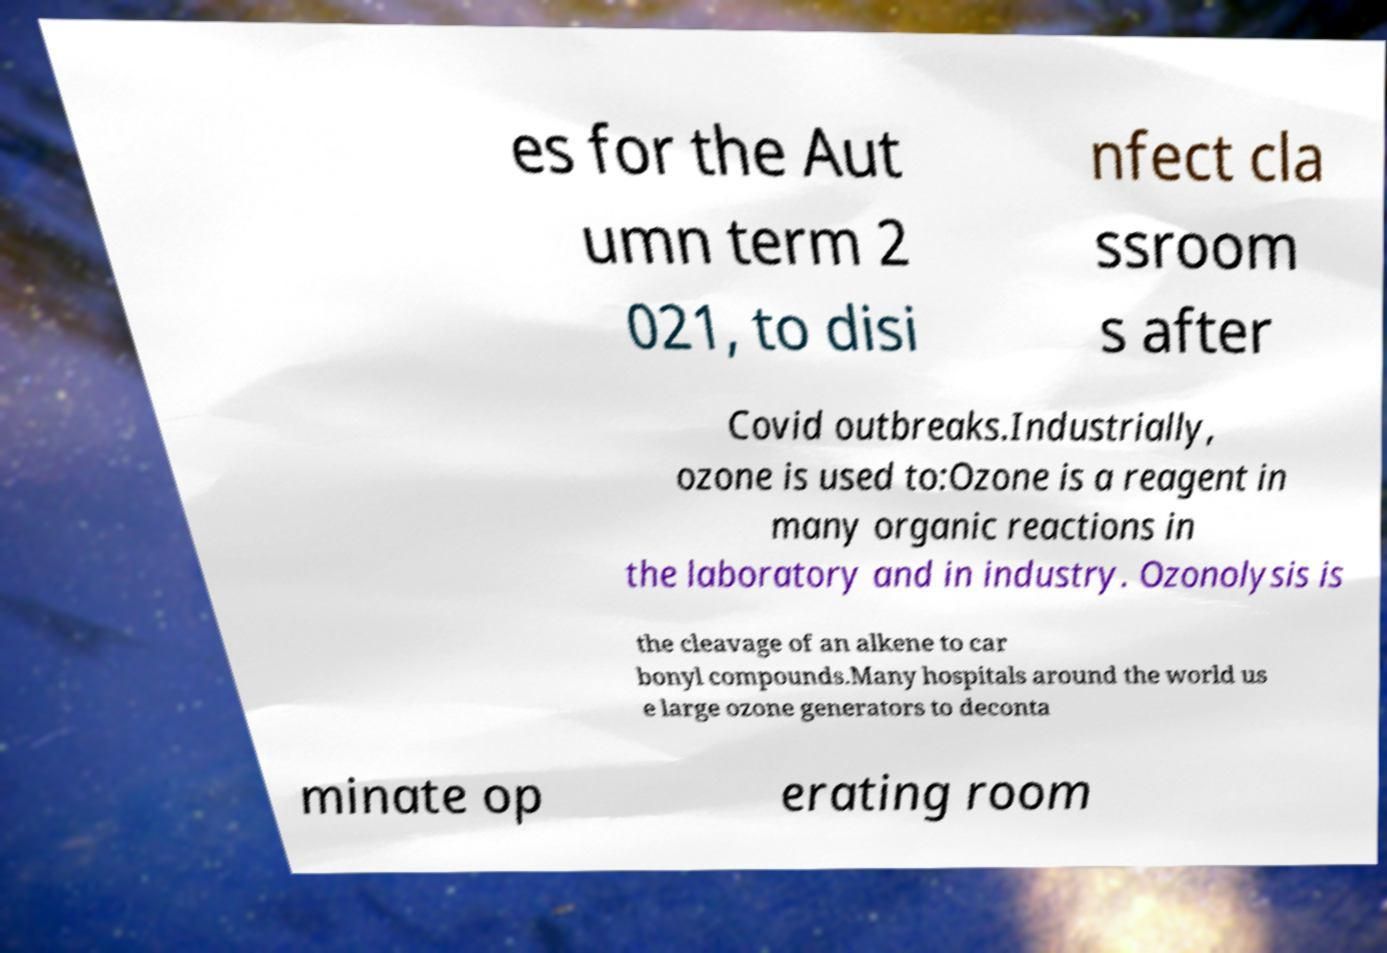Can you read and provide the text displayed in the image?This photo seems to have some interesting text. Can you extract and type it out for me? es for the Aut umn term 2 021, to disi nfect cla ssroom s after Covid outbreaks.Industrially, ozone is used to:Ozone is a reagent in many organic reactions in the laboratory and in industry. Ozonolysis is the cleavage of an alkene to car bonyl compounds.Many hospitals around the world us e large ozone generators to deconta minate op erating room 